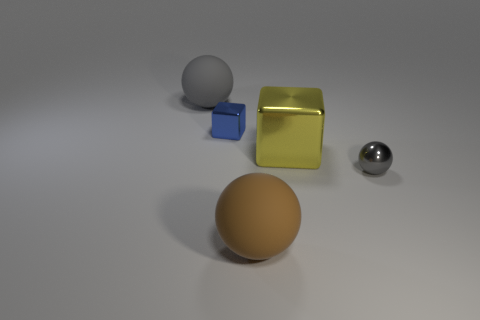Subtract all small metallic spheres. How many spheres are left? 2 Subtract all brown balls. How many balls are left? 2 Add 1 gray balls. How many objects exist? 6 Subtract all cubes. How many objects are left? 3 Subtract 1 balls. How many balls are left? 2 Subtract all purple cubes. How many gray balls are left? 2 Subtract 0 red spheres. How many objects are left? 5 Subtract all blue blocks. Subtract all red cylinders. How many blocks are left? 1 Subtract all green metallic cubes. Subtract all small blue metallic cubes. How many objects are left? 4 Add 1 large shiny cubes. How many large shiny cubes are left? 2 